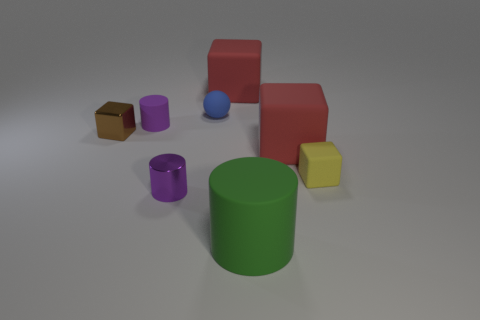What size is the brown thing that is the same shape as the small yellow thing?
Give a very brief answer. Small. Is the number of blue rubber spheres greater than the number of yellow rubber cylinders?
Make the answer very short. Yes. Is the brown metallic thing the same shape as the green matte object?
Offer a terse response. No. The red object in front of the small purple object that is behind the tiny yellow object is made of what material?
Make the answer very short. Rubber. What material is the small thing that is the same color as the tiny rubber cylinder?
Ensure brevity in your answer.  Metal. Is the yellow rubber block the same size as the blue object?
Offer a terse response. Yes. Is there a big rubber block behind the rubber cylinder left of the shiny cylinder?
Your answer should be very brief. Yes. There is a matte thing that is the same color as the tiny metal cylinder; what size is it?
Offer a very short reply. Small. There is a small metallic thing that is behind the small rubber block; what is its shape?
Your answer should be compact. Cube. There is a small cube on the left side of the red thing that is left of the green object; what number of small brown shiny objects are behind it?
Make the answer very short. 0. 